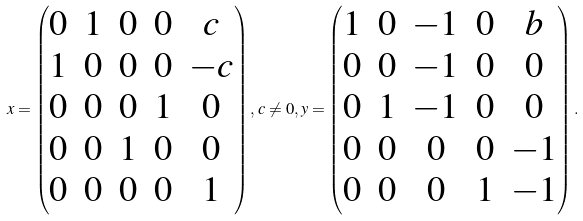<formula> <loc_0><loc_0><loc_500><loc_500>x = \begin{pmatrix} 0 & 1 & 0 & 0 & c \\ 1 & 0 & 0 & 0 & - c \\ 0 & 0 & 0 & 1 & 0 \\ 0 & 0 & 1 & 0 & 0 \\ 0 & 0 & 0 & 0 & 1 \end{pmatrix} , \, c \neq 0 , y = \begin{pmatrix} 1 & 0 & - 1 & 0 & b \\ 0 & 0 & - 1 & 0 & 0 \\ 0 & 1 & - 1 & 0 & 0 \\ 0 & 0 & 0 & 0 & - 1 \\ 0 & 0 & 0 & 1 & - 1 \end{pmatrix} .</formula> 